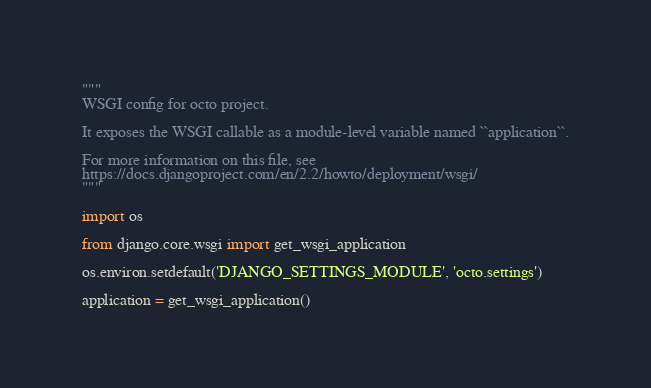<code> <loc_0><loc_0><loc_500><loc_500><_Python_>"""
WSGI config for octo project.

It exposes the WSGI callable as a module-level variable named ``application``.

For more information on this file, see
https://docs.djangoproject.com/en/2.2/howto/deployment/wsgi/
"""

import os

from django.core.wsgi import get_wsgi_application

os.environ.setdefault('DJANGO_SETTINGS_MODULE', 'octo.settings')

application = get_wsgi_application()
</code> 